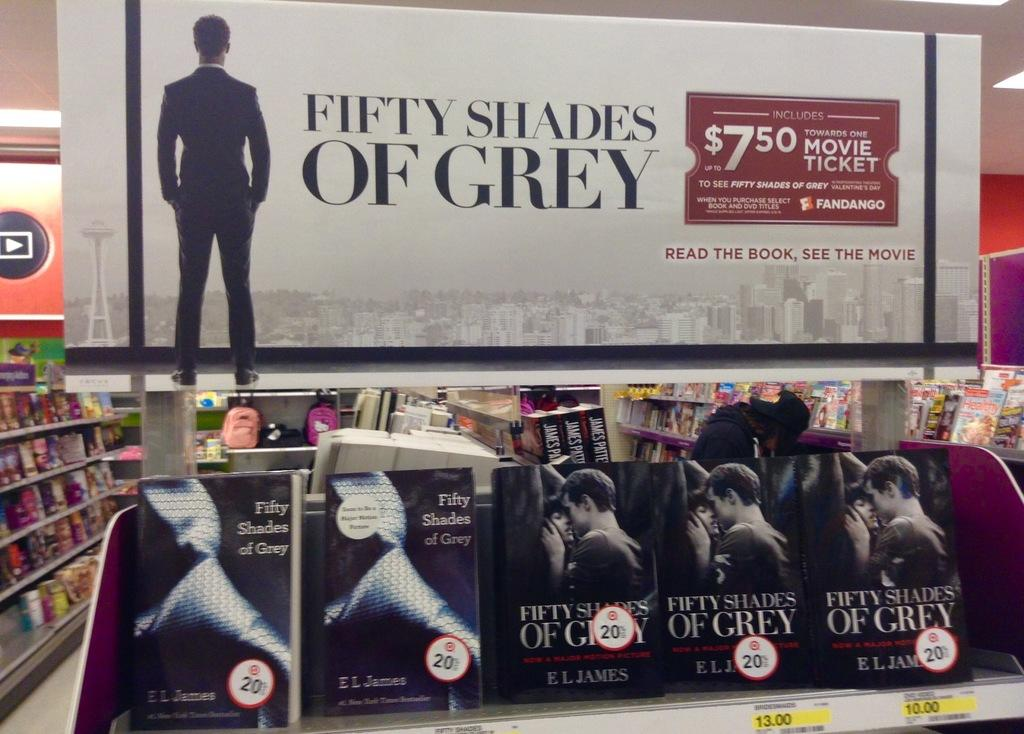<image>
Write a terse but informative summary of the picture. Fifty Shades of Grey movies for sale inside a store. 